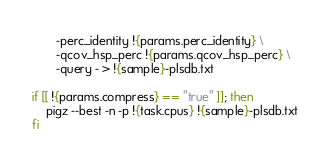<code> <loc_0><loc_0><loc_500><loc_500><_Bash_>       -perc_identity !{params.perc_identity} \
       -qcov_hsp_perc !{params.qcov_hsp_perc} \
       -query - > !{sample}-plsdb.txt

if [[ !{params.compress} == "true" ]]; then
    pigz --best -n -p !{task.cpus} !{sample}-plsdb.txt
fi
</code> 